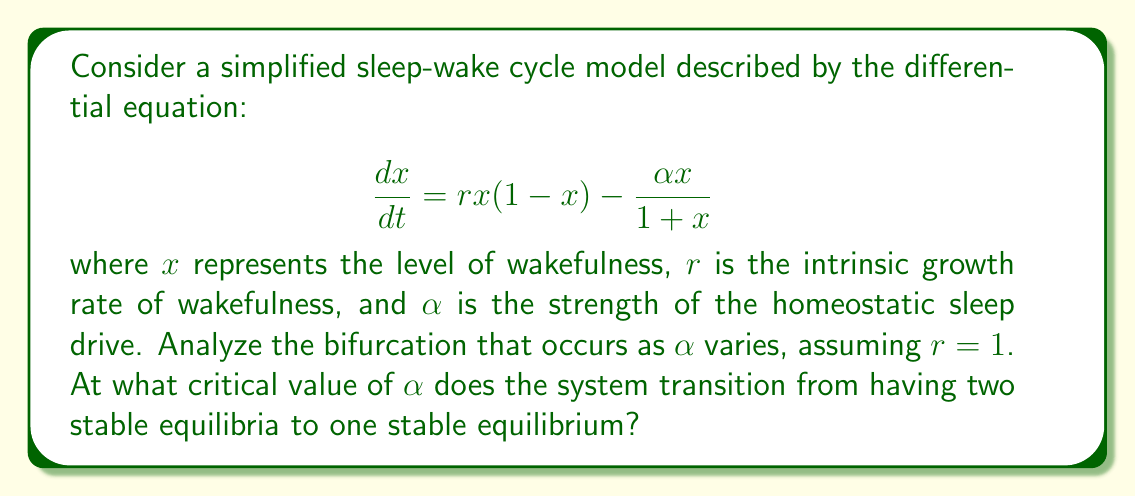Show me your answer to this math problem. 1. First, we need to find the equilibria of the system by setting $\frac{dx}{dt} = 0$:

   $$0 = rx(1-x) - \frac{\alpha x}{1+x}$$

2. Assuming $r=1$, we have:

   $$0 = x(1-x) - \frac{\alpha x}{1+x}$$

3. Multiply both sides by $(1+x)$:

   $$0 = x(1-x)(1+x) - \alpha x$$

4. Expand the equation:

   $$0 = x + x^2 - x^2 - x^3 - \alpha x = x - x^3 - \alpha x$$

5. Factor out $x$:

   $$0 = x(1 - x^2 - \alpha)$$

6. The equilibria are given by $x=0$ and the solutions to $1 - x^2 - \alpha = 0$.

7. Solve for $x^2$:

   $$x^2 = 1 - \alpha$$

8. A bifurcation occurs when the non-zero equilibria disappear, which happens when $1 - \alpha = 0$.

9. Solve for the critical value of $\alpha$:

   $$\alpha_{critical} = 1$$

10. For $\alpha < 1$, there are two non-zero equilibria (in addition to $x=0$). For $\alpha > 1$, only the $x=0$ equilibrium exists.

11. To determine stability, we can analyze the derivative of $\frac{dx}{dt}$ with respect to $x$ at each equilibrium point. The transition from two stable equilibria to one stable equilibrium occurs at $\alpha = 1$.
Answer: $\alpha_{critical} = 1$ 